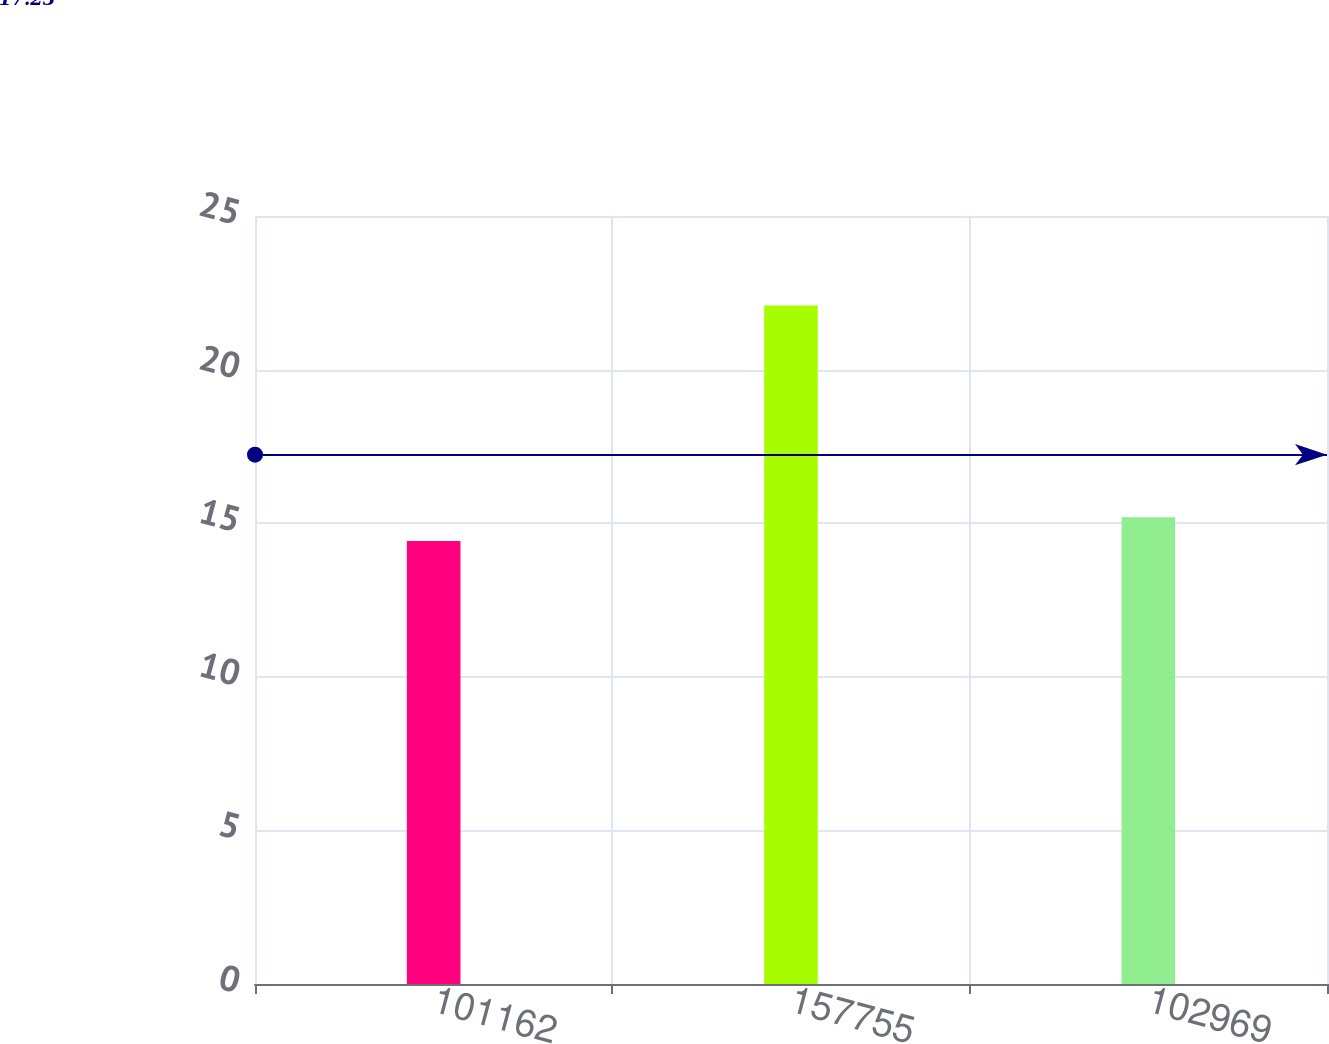Convert chart to OTSL. <chart><loc_0><loc_0><loc_500><loc_500><bar_chart><fcel>101162<fcel>157755<fcel>102969<nl><fcel>14.42<fcel>22.09<fcel>15.19<nl></chart> 